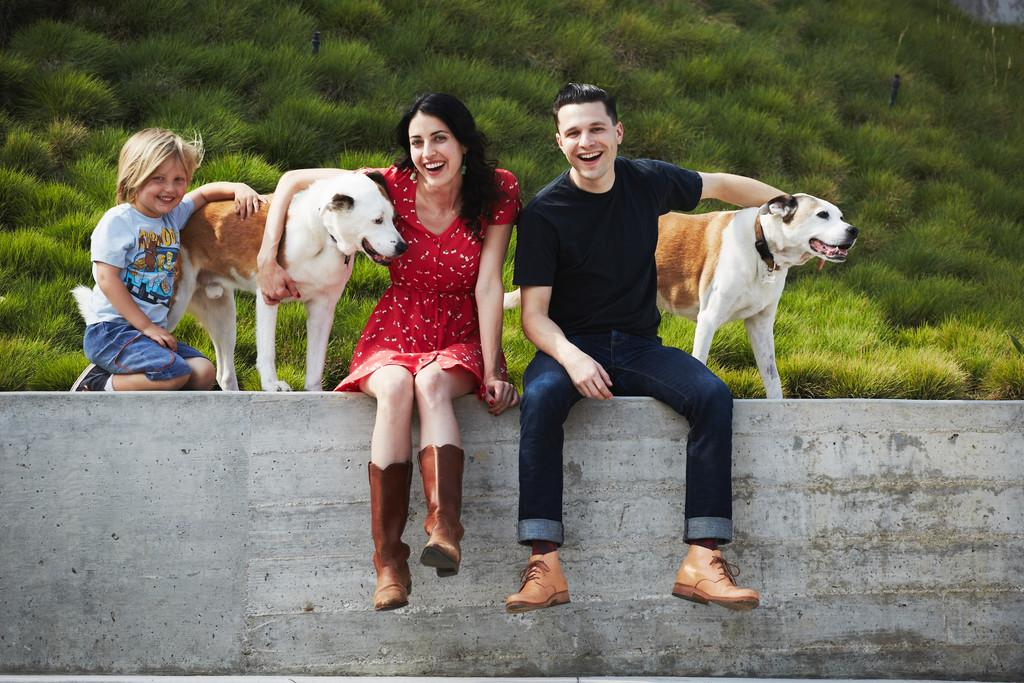How many people are in the image? There are two persons in the image. Can you describe one of the persons? One of the persons is a boy. What other living beings are present in the image? There are two dogs in the image. Where are the persons and dogs located in the image? The persons and dogs are sitting on a wall. What can be seen in the background of the image? There is grass visible in the background of the image. What type of verse is being recited on the stage in the image? There is no stage present in the image, and therefore no verse being recited. Can you tell me how many zippers are visible on the dogs in the image? There are no zippers visible on the dogs in the image. 